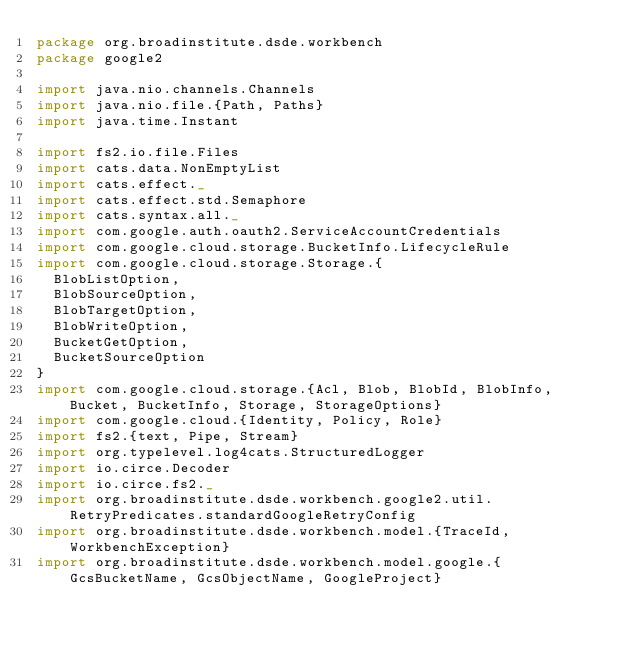Convert code to text. <code><loc_0><loc_0><loc_500><loc_500><_Scala_>package org.broadinstitute.dsde.workbench
package google2

import java.nio.channels.Channels
import java.nio.file.{Path, Paths}
import java.time.Instant

import fs2.io.file.Files
import cats.data.NonEmptyList
import cats.effect._
import cats.effect.std.Semaphore
import cats.syntax.all._
import com.google.auth.oauth2.ServiceAccountCredentials
import com.google.cloud.storage.BucketInfo.LifecycleRule
import com.google.cloud.storage.Storage.{
  BlobListOption,
  BlobSourceOption,
  BlobTargetOption,
  BlobWriteOption,
  BucketGetOption,
  BucketSourceOption
}
import com.google.cloud.storage.{Acl, Blob, BlobId, BlobInfo, Bucket, BucketInfo, Storage, StorageOptions}
import com.google.cloud.{Identity, Policy, Role}
import fs2.{text, Pipe, Stream}
import org.typelevel.log4cats.StructuredLogger
import io.circe.Decoder
import io.circe.fs2._
import org.broadinstitute.dsde.workbench.google2.util.RetryPredicates.standardGoogleRetryConfig
import org.broadinstitute.dsde.workbench.model.{TraceId, WorkbenchException}
import org.broadinstitute.dsde.workbench.model.google.{GcsBucketName, GcsObjectName, GoogleProject}</code> 